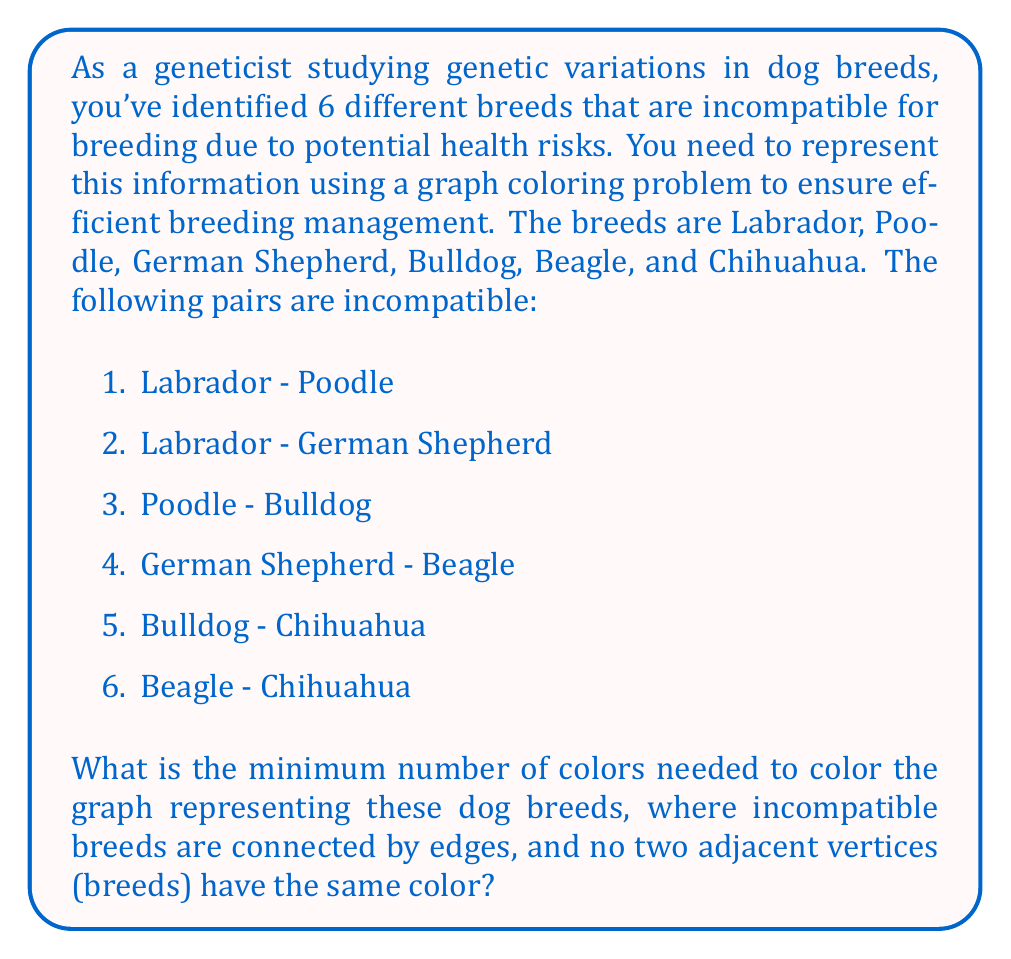Can you answer this question? To solve this graph coloring problem, we'll follow these steps:

1. Create a graph where each vertex represents a dog breed, and edges connect incompatible breeds.

2. Apply a greedy coloring algorithm to find the minimum number of colors needed.

Let's start by creating the graph:

[asy]
unitsize(1cm);

pair[] vertices = {(0,0), (2,0), (1,1.732), (-1,1.732), (-2,0), (0,-2)};
string[] labels = {"L", "P", "GS", "B", "BD", "C"};

for(int i = 0; i < 6; ++i) {
  dot(vertices[i]);
  label(labels[i], vertices[i], N);
}

draw(vertices[0]--vertices[1]);  // L-P
draw(vertices[0]--vertices[2]);  // L-GS
draw(vertices[1]--vertices[4]);  // P-BD
draw(vertices[2]--vertices[3]);  // GS-B
draw(vertices[3]--vertices[5]);  // B-C
draw(vertices[4]--vertices[5]);  // BD-C
[/asy]

Now, let's apply the greedy coloring algorithm:

1. Start with Labrador (L) and assign it color 1.
2. Move to Poodle (P). It's adjacent to L, so assign it color 2.
3. German Shepherd (GS) is adjacent to L, so it can't be color 1. Assign it color 2.
4. Bulldog (BD) is adjacent to P (color 2), so assign it color 1.
5. Beagle (B) is adjacent to GS (color 2), so assign it color 1.
6. Chihuahua (C) is adjacent to BD and B (both color 1), so assign it color 2.

The final coloring:
- Color 1: Labrador, Bulldog, Beagle
- Color 2: Poodle, German Shepherd, Chihuahua

We've successfully colored the graph using only 2 colors, and no adjacent vertices have the same color.
Answer: The minimum number of colors needed to color the graph is 2. 